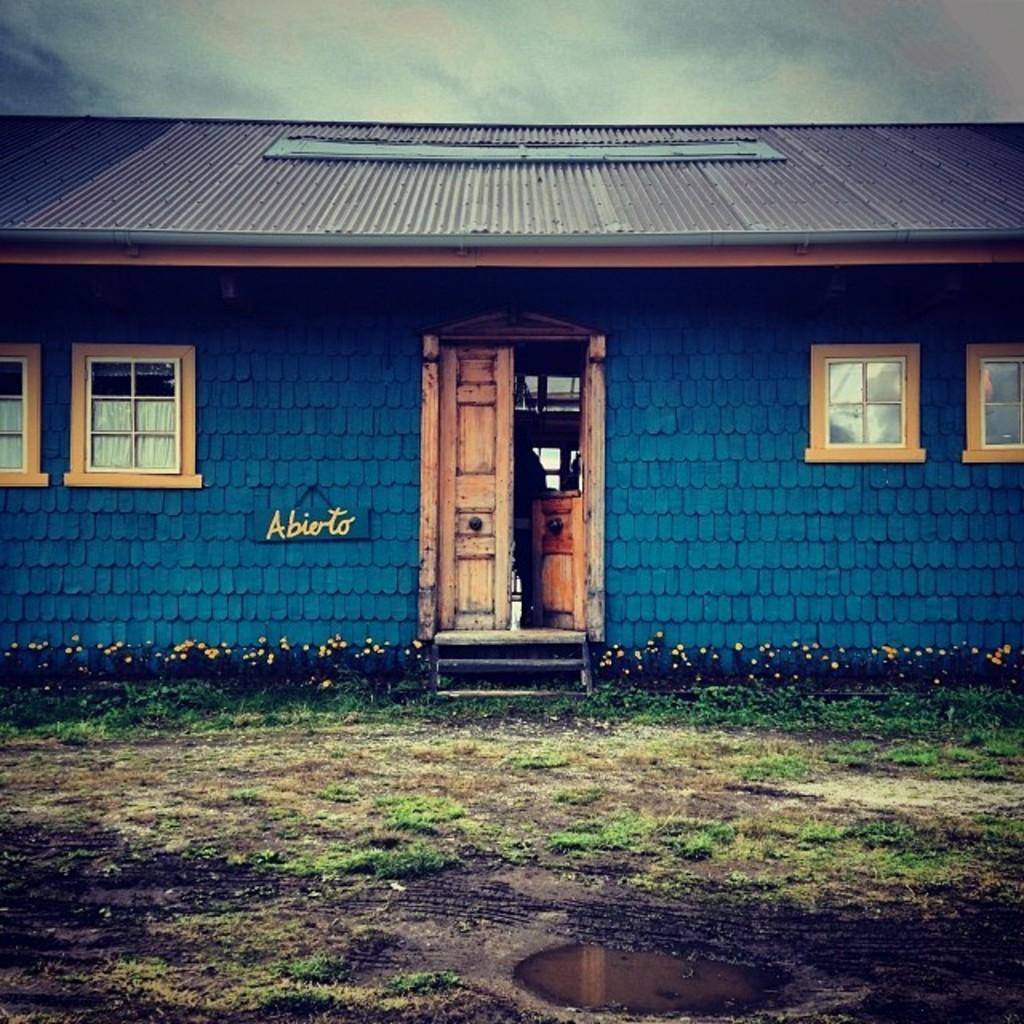How would you summarize this image in a sentence or two? In this picture I can see a house and few plants with flowers and few Windows and a door and I can see water on the ground and a cloudy sky and some text on the board on the left side of the wall. 